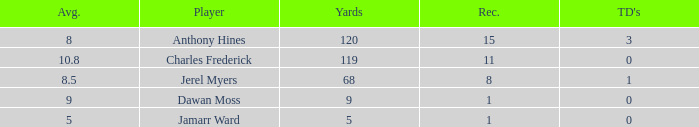What is the total Avg when TDs are 0 and Dawan Moss is a player? 0.0. 